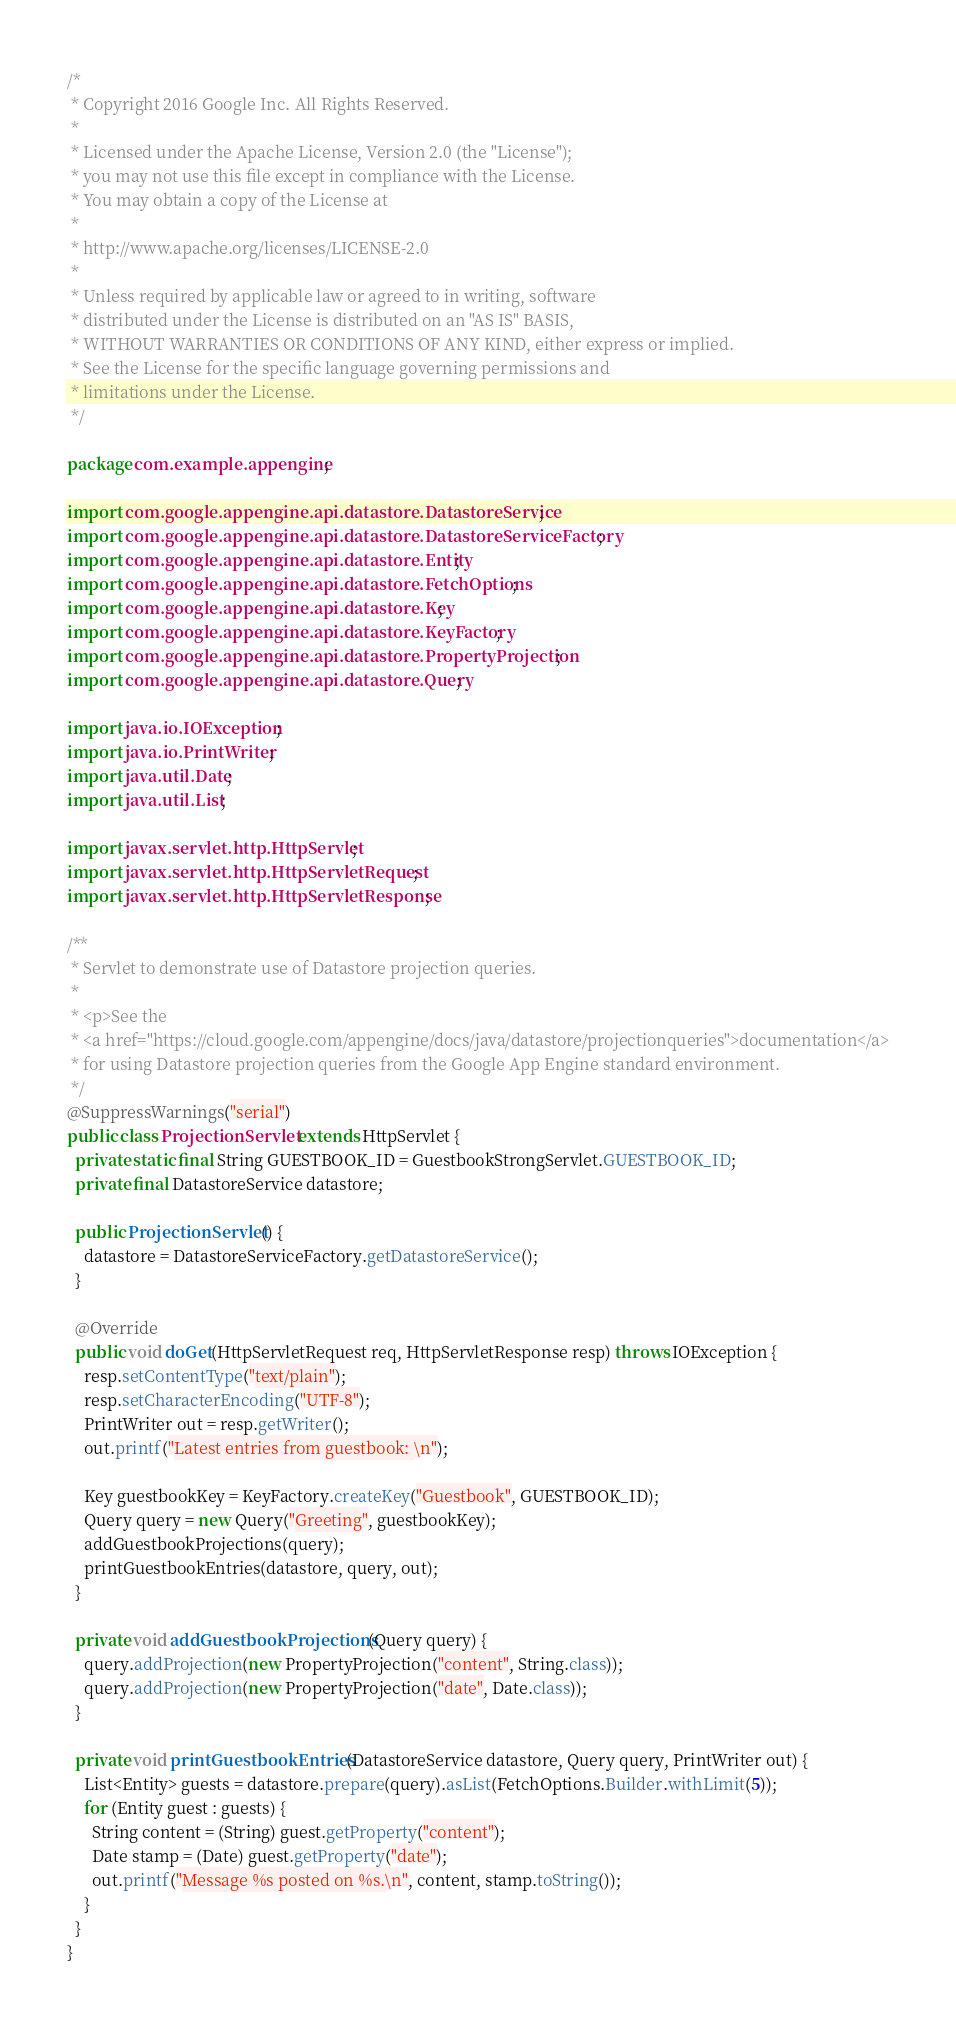Convert code to text. <code><loc_0><loc_0><loc_500><loc_500><_Java_>/*
 * Copyright 2016 Google Inc. All Rights Reserved.
 *
 * Licensed under the Apache License, Version 2.0 (the "License");
 * you may not use this file except in compliance with the License.
 * You may obtain a copy of the License at
 *
 * http://www.apache.org/licenses/LICENSE-2.0
 *
 * Unless required by applicable law or agreed to in writing, software
 * distributed under the License is distributed on an "AS IS" BASIS,
 * WITHOUT WARRANTIES OR CONDITIONS OF ANY KIND, either express or implied.
 * See the License for the specific language governing permissions and
 * limitations under the License.
 */

package com.example.appengine;

import com.google.appengine.api.datastore.DatastoreService;
import com.google.appengine.api.datastore.DatastoreServiceFactory;
import com.google.appengine.api.datastore.Entity;
import com.google.appengine.api.datastore.FetchOptions;
import com.google.appengine.api.datastore.Key;
import com.google.appengine.api.datastore.KeyFactory;
import com.google.appengine.api.datastore.PropertyProjection;
import com.google.appengine.api.datastore.Query;

import java.io.IOException;
import java.io.PrintWriter;
import java.util.Date;
import java.util.List;

import javax.servlet.http.HttpServlet;
import javax.servlet.http.HttpServletRequest;
import javax.servlet.http.HttpServletResponse;

/**
 * Servlet to demonstrate use of Datastore projection queries.
 *
 * <p>See the
 * <a href="https://cloud.google.com/appengine/docs/java/datastore/projectionqueries">documentation</a>
 * for using Datastore projection queries from the Google App Engine standard environment.
 */
@SuppressWarnings("serial")
public class ProjectionServlet extends HttpServlet {
  private static final String GUESTBOOK_ID = GuestbookStrongServlet.GUESTBOOK_ID;
  private final DatastoreService datastore;

  public ProjectionServlet() {
    datastore = DatastoreServiceFactory.getDatastoreService();
  }

  @Override
  public void doGet(HttpServletRequest req, HttpServletResponse resp) throws IOException {
    resp.setContentType("text/plain");
    resp.setCharacterEncoding("UTF-8");
    PrintWriter out = resp.getWriter();
    out.printf("Latest entries from guestbook: \n");

    Key guestbookKey = KeyFactory.createKey("Guestbook", GUESTBOOK_ID);
    Query query = new Query("Greeting", guestbookKey);
    addGuestbookProjections(query);
    printGuestbookEntries(datastore, query, out);
  }

  private void addGuestbookProjections(Query query) {
    query.addProjection(new PropertyProjection("content", String.class));
    query.addProjection(new PropertyProjection("date", Date.class));
  }

  private void printGuestbookEntries(DatastoreService datastore, Query query, PrintWriter out) {
    List<Entity> guests = datastore.prepare(query).asList(FetchOptions.Builder.withLimit(5));
    for (Entity guest : guests) {
      String content = (String) guest.getProperty("content");
      Date stamp = (Date) guest.getProperty("date");
      out.printf("Message %s posted on %s.\n", content, stamp.toString());
    }
  }
}
</code> 